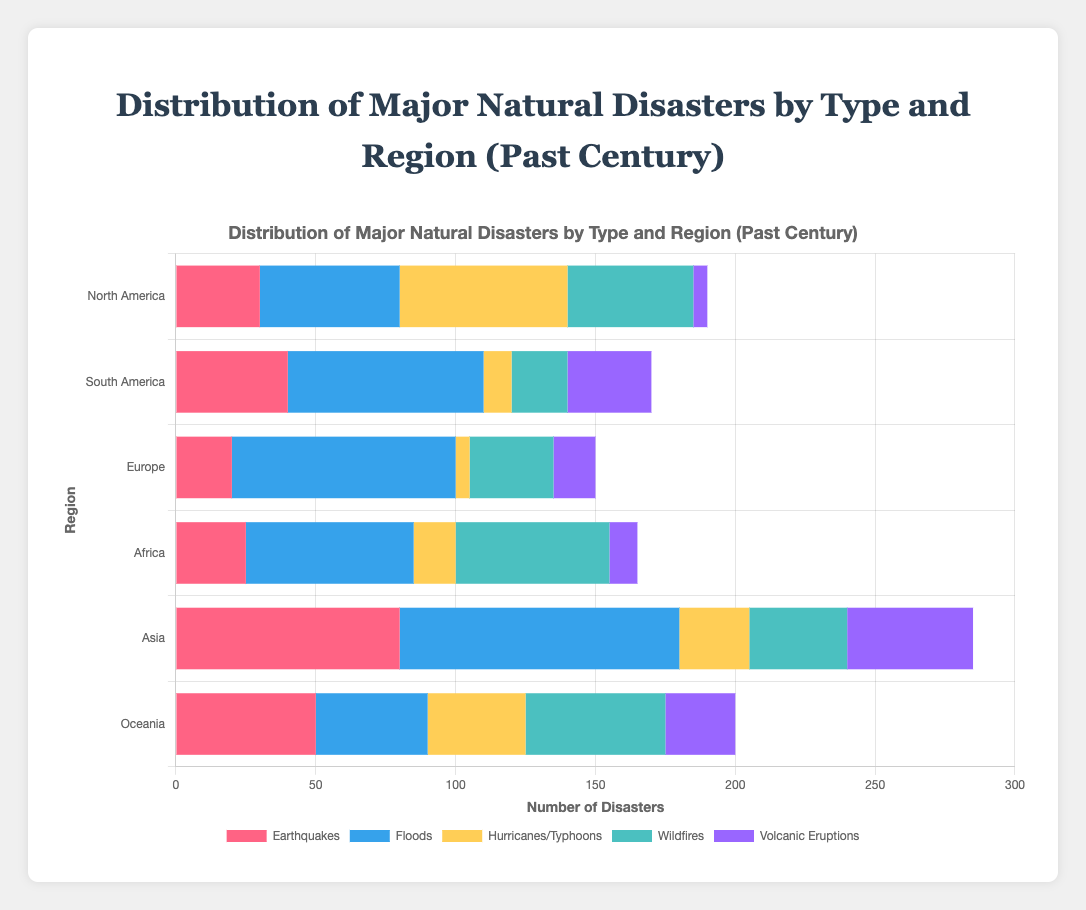Which region has experienced the highest number of earthquakes? By looking at the "Earthquakes" bars, we observe that "Asia" has the longest bar, indicating the highest number of earthquakes, which is 80.
Answer: Asia Which region has the least number of volcanic eruptions? The bar for "Volcanic Eruptions" in "North America" is the shortest, indicating the least number of volcanic eruptions, which is 5.
Answer: North America What is the total number of natural disasters in Europe? Add up the numbers for each disaster type in Europe: 20 (Earthquakes) + 80 (Floods) + 5 (Hurricanes/Typhoons) + 30 (Wildfires) + 15 (Volcanic Eruptions) = 150.
Answer: 150 Comparing North America and Oceania, which region has more wildfires, and by how much? North America has 45 wildfires, and Oceania has 50 wildfires. The difference is 50 - 45 = 5, so Oceania has 5 more wildfires than North America.
Answer: Oceania, 5 Which disaster type is the most common in South America? The "Floods" bar is the longest for South America, indicating that floods are the most common disaster type with a count of 70.
Answer: Floods What are the total earthquakes reported in Africa and Oceania combined? Africa has 25 earthquakes and Oceania has 50 earthquakes. The combined total is 25 + 50 = 75.
Answer: 75 Which region has the highest number of hurricanes/typhoons, and what is the count? By examining the "Hurricanes/Typhoons" bars, North America has the highest count with 60 hurricanes/typhoons.
Answer: North America, 60 What is the difference in the total number of floods between Asia and North America? Asia has 100 floods, and North America has 50 floods. The difference is 100 - 50 = 50.
Answer: 50 Which region has the most balanced distribution across different types of natural disasters? By visual inspection, Oceania appears to have a more balanced distribution, with relatively similar lengths for each disaster type's bar.
Answer: Oceania How many more earthquakes does Asia have compared to Europe? Asia has 80 earthquakes, while Europe has 20 earthquakes. The difference is 80 - 20 = 60.
Answer: 60 